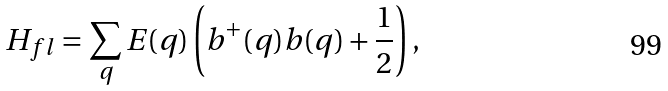Convert formula to latex. <formula><loc_0><loc_0><loc_500><loc_500>H _ { f l } = \sum _ { q } E ( q ) \left ( b ^ { + } ( q ) b ( q ) + \frac { 1 } { 2 } \right ) ,</formula> 